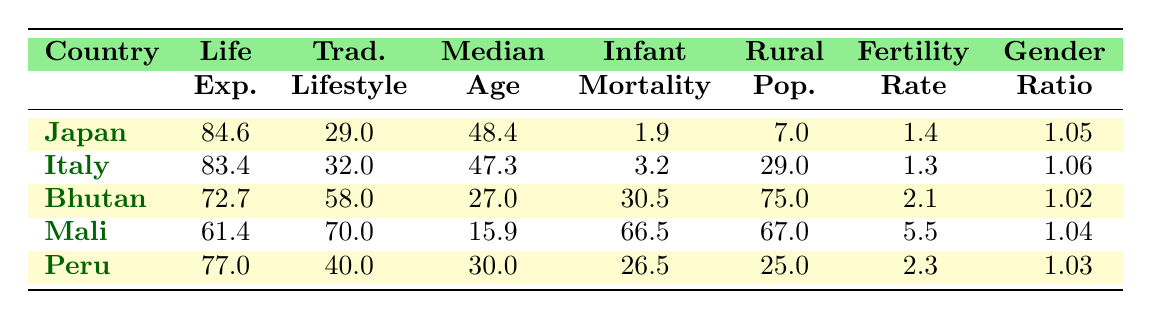What is the life expectancy in Italy? The table shows that the life expectancy for Italy is listed directly under that country's name in the life expectancy column. Looking at the values, we see that it is 83.4 years.
Answer: 83.4 Which country has the highest traditional lifestyle percentage? By examining the traditional lifestyle percentage column, we see the values: Japan (29), Italy (32), Bhutan (58), Mali (70), and Peru (40). Mali has the highest percentage at 70%.
Answer: Mali What is the difference in life expectancy between Bhutan and Mali? Life expectancy for Bhutan is 72.7 and for Mali it is 61.4. Subtracting these values gives 72.7 - 61.4 = 11.3 years.
Answer: 11.3 Is the fertility rate in Peru higher than that in Japan? The fertility rate for Peru is 2.3, whereas for Japan it is 1.4. Since 2.3 is greater than 1.4, this statement is true.
Answer: Yes What is the median age of the country with the lowest fertility rate? Looking through the fertility rate column, we see that Japan has the lowest fertility rate at 1.4. The corresponding median age for Japan is 48.4 years.
Answer: 48.4 Calculate the average infant mortality rate of all countries presented. The infant mortality rates are: Japan (1.9), Italy (3.2), Bhutan (30.5), Mali (66.5), Peru (26.5). Summing these gives 1.9 + 3.2 + 30.5 + 66.5 + 26.5 = 128.6. Dividing by the number of countries (5) gives an average of 128.6 / 5 = 25.72.
Answer: 25.72 Does Bhutan have a higher rural population percentage compared to Italy? Bhutan has a rural population percentage of 75%, while Italy's is 29%. Thus, Bhutan's rural population percentage is much higher.
Answer: Yes What is the gender ratio at birth for Mali? The gender ratio at birth for Mali is stated in the table, looking specifically at that row, we find it is 1.04.
Answer: 1.04 What is the relationship between traditional lifestyle percentage and life expectancy for the countries listed? To analyze the relationship, we look at the traditional lifestyle percentages and corresponding life expectancies: Japan (29, 84.6), Italy (32, 83.4), Bhutan (58, 72.7), Mali (70, 61.4), and Peru (40, 77.0). Generally, higher traditional lifestyle percentages correspond to lower life expectancies, indicating an inverse relationship.
Answer: Inverse relationship 